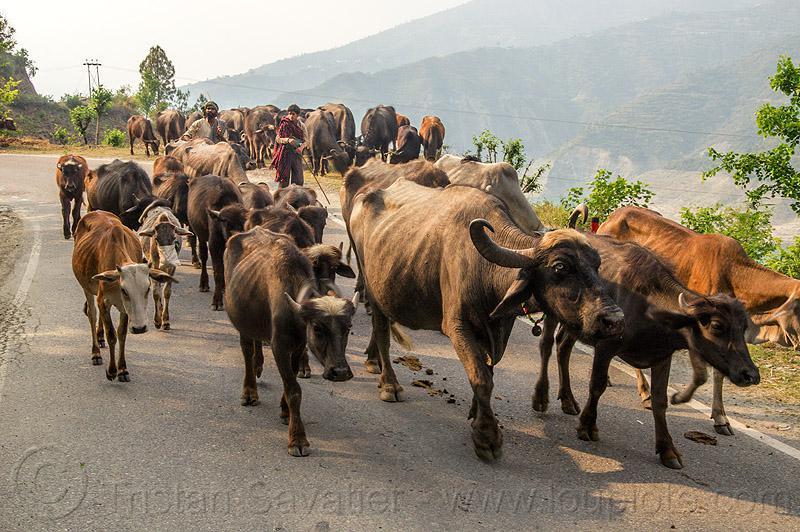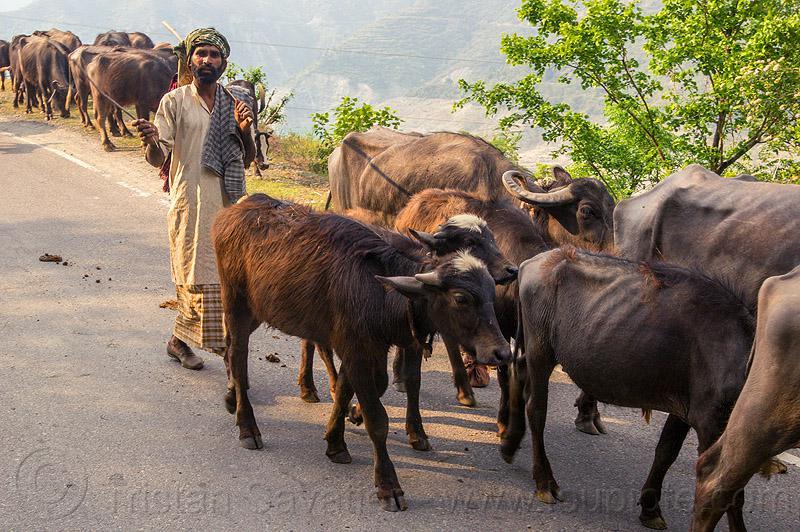The first image is the image on the left, the second image is the image on the right. For the images displayed, is the sentence "Each image shows multiple horned animals standing at least chest-deep in water, and one image includes some animals standing behind water on higher ground near a fence." factually correct? Answer yes or no. No. The first image is the image on the left, the second image is the image on the right. Analyze the images presented: Is the assertion "None of the animals are completely in the water." valid? Answer yes or no. Yes. 